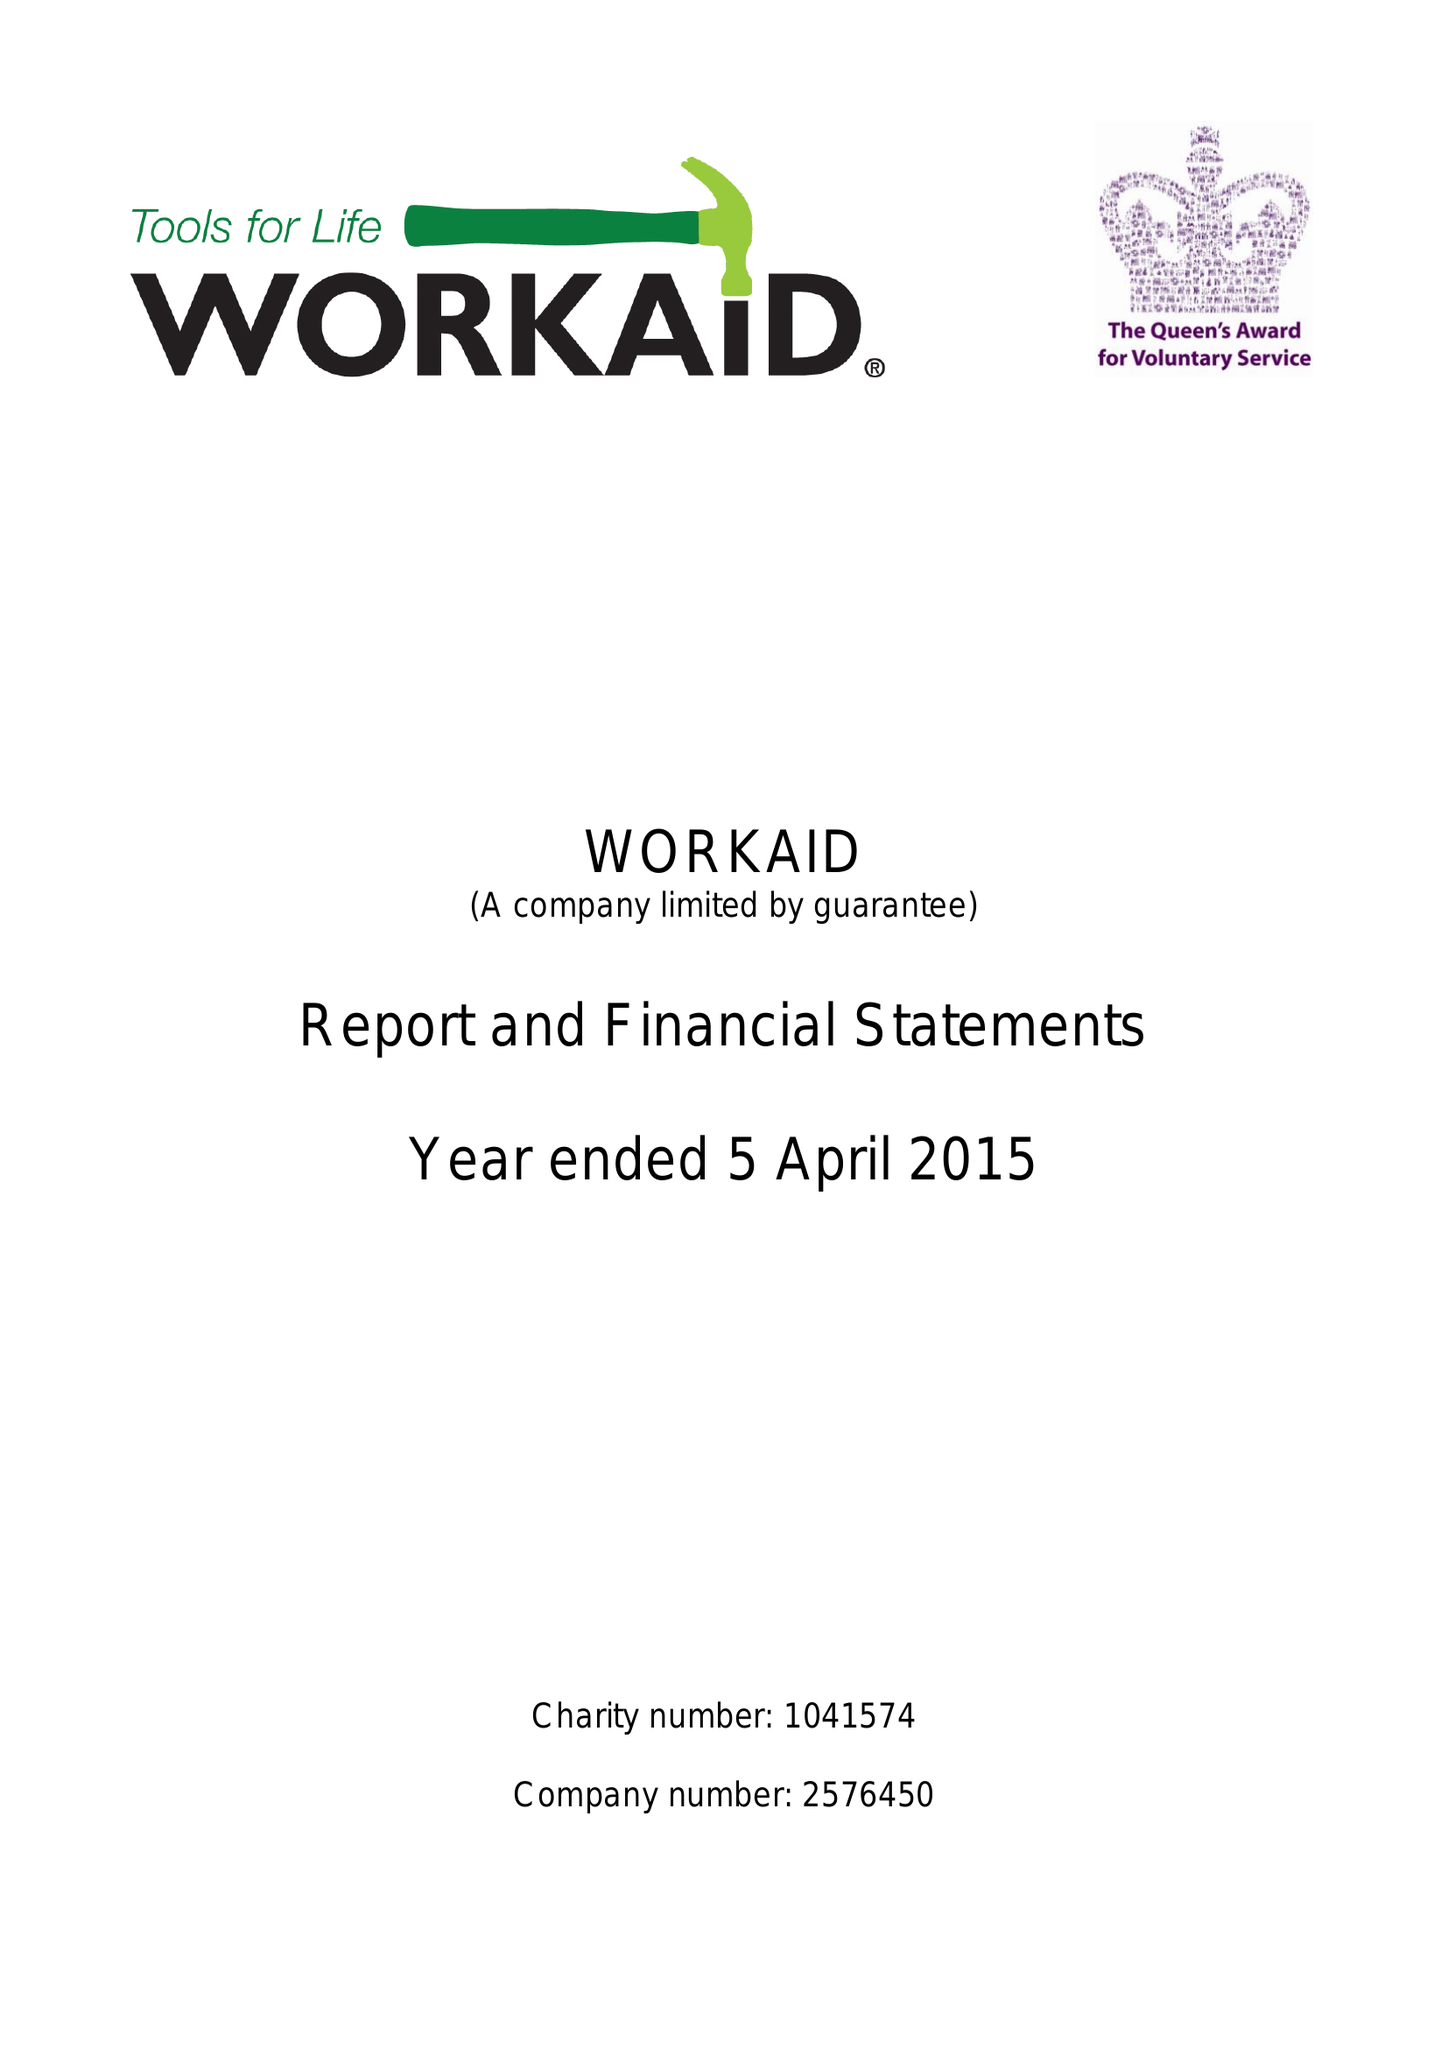What is the value for the address__postcode?
Answer the question using a single word or phrase. HP5 2AA 